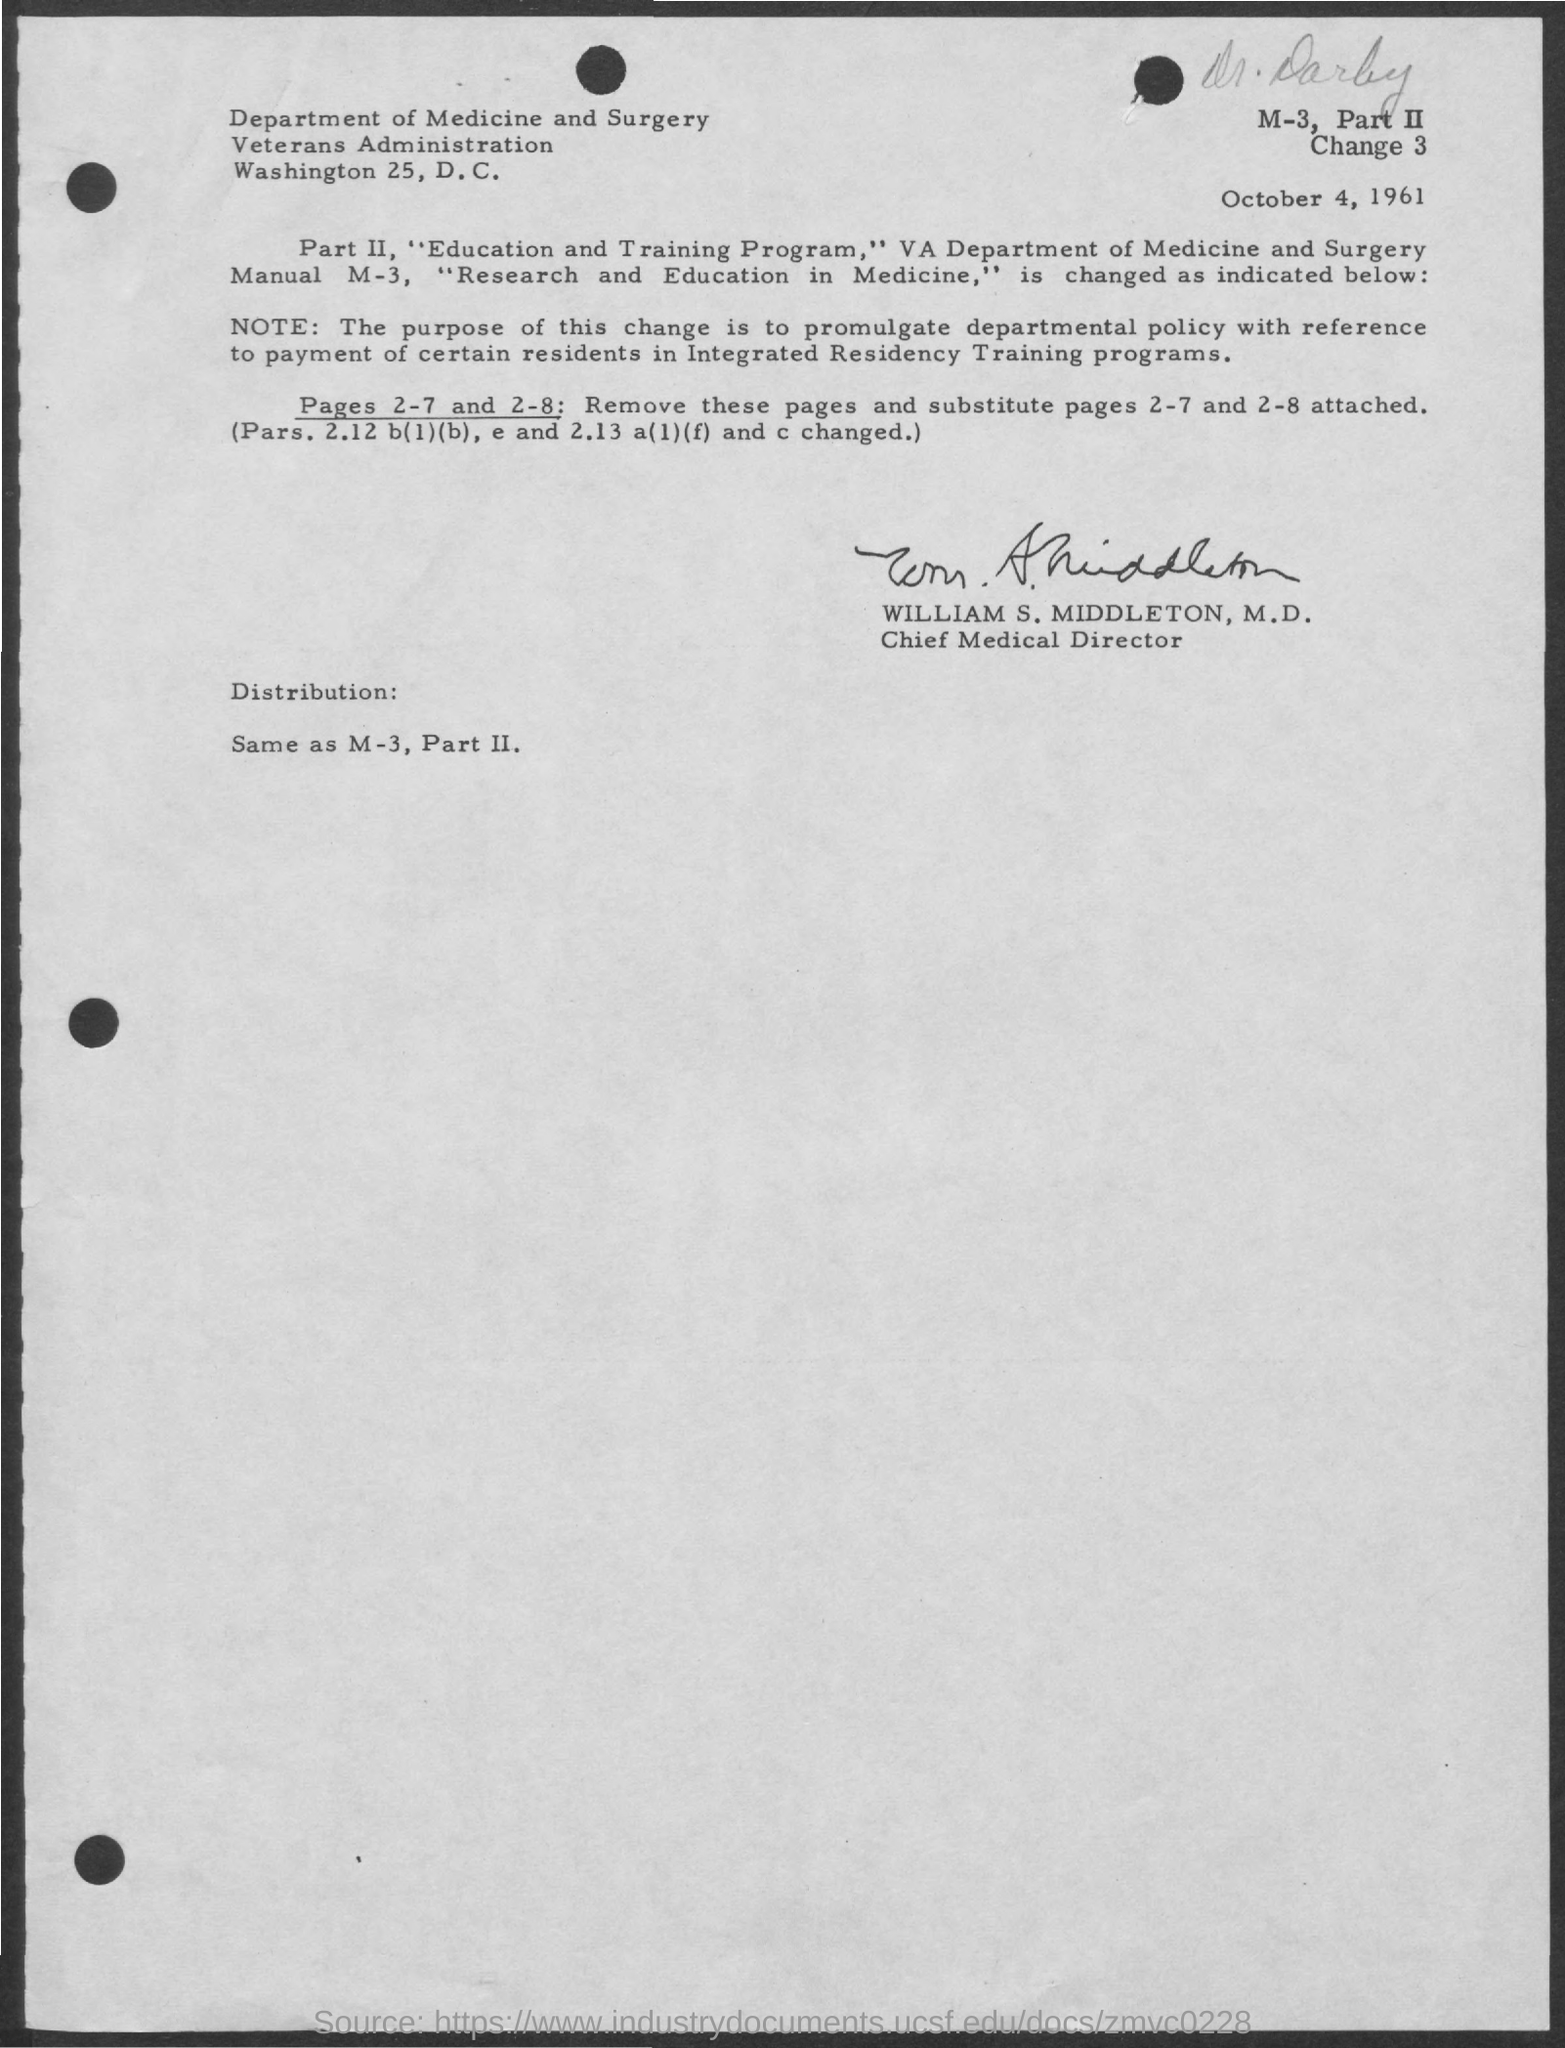Who is the chief medical director?
Keep it short and to the point. WILLIAM S. MIDDLETON. What is the date mentioned in document?
Make the answer very short. October 4, 1961. 